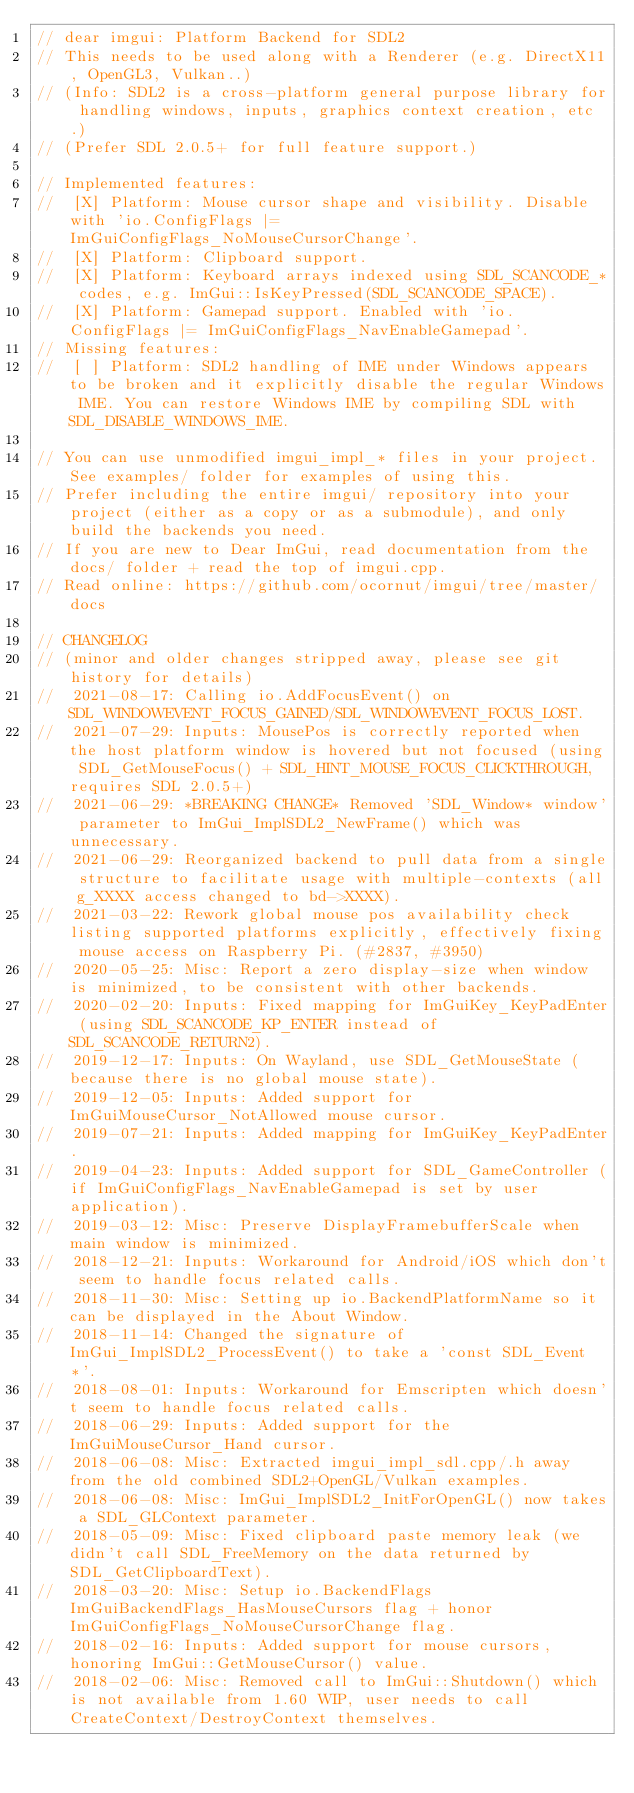Convert code to text. <code><loc_0><loc_0><loc_500><loc_500><_C++_>// dear imgui: Platform Backend for SDL2
// This needs to be used along with a Renderer (e.g. DirectX11, OpenGL3, Vulkan..)
// (Info: SDL2 is a cross-platform general purpose library for handling windows, inputs, graphics context creation, etc.)
// (Prefer SDL 2.0.5+ for full feature support.)

// Implemented features:
//  [X] Platform: Mouse cursor shape and visibility. Disable with 'io.ConfigFlags |= ImGuiConfigFlags_NoMouseCursorChange'.
//  [X] Platform: Clipboard support.
//  [X] Platform: Keyboard arrays indexed using SDL_SCANCODE_* codes, e.g. ImGui::IsKeyPressed(SDL_SCANCODE_SPACE).
//  [X] Platform: Gamepad support. Enabled with 'io.ConfigFlags |= ImGuiConfigFlags_NavEnableGamepad'.
// Missing features:
//  [ ] Platform: SDL2 handling of IME under Windows appears to be broken and it explicitly disable the regular Windows IME. You can restore Windows IME by compiling SDL with SDL_DISABLE_WINDOWS_IME.

// You can use unmodified imgui_impl_* files in your project. See examples/ folder for examples of using this.
// Prefer including the entire imgui/ repository into your project (either as a copy or as a submodule), and only build the backends you need.
// If you are new to Dear ImGui, read documentation from the docs/ folder + read the top of imgui.cpp.
// Read online: https://github.com/ocornut/imgui/tree/master/docs

// CHANGELOG
// (minor and older changes stripped away, please see git history for details)
//  2021-08-17: Calling io.AddFocusEvent() on SDL_WINDOWEVENT_FOCUS_GAINED/SDL_WINDOWEVENT_FOCUS_LOST.
//  2021-07-29: Inputs: MousePos is correctly reported when the host platform window is hovered but not focused (using SDL_GetMouseFocus() + SDL_HINT_MOUSE_FOCUS_CLICKTHROUGH, requires SDL 2.0.5+)
//  2021-06-29: *BREAKING CHANGE* Removed 'SDL_Window* window' parameter to ImGui_ImplSDL2_NewFrame() which was unnecessary.
//  2021-06-29: Reorganized backend to pull data from a single structure to facilitate usage with multiple-contexts (all g_XXXX access changed to bd->XXXX).
//  2021-03-22: Rework global mouse pos availability check listing supported platforms explicitly, effectively fixing mouse access on Raspberry Pi. (#2837, #3950)
//  2020-05-25: Misc: Report a zero display-size when window is minimized, to be consistent with other backends.
//  2020-02-20: Inputs: Fixed mapping for ImGuiKey_KeyPadEnter (using SDL_SCANCODE_KP_ENTER instead of SDL_SCANCODE_RETURN2).
//  2019-12-17: Inputs: On Wayland, use SDL_GetMouseState (because there is no global mouse state).
//  2019-12-05: Inputs: Added support for ImGuiMouseCursor_NotAllowed mouse cursor.
//  2019-07-21: Inputs: Added mapping for ImGuiKey_KeyPadEnter.
//  2019-04-23: Inputs: Added support for SDL_GameController (if ImGuiConfigFlags_NavEnableGamepad is set by user application).
//  2019-03-12: Misc: Preserve DisplayFramebufferScale when main window is minimized.
//  2018-12-21: Inputs: Workaround for Android/iOS which don't seem to handle focus related calls.
//  2018-11-30: Misc: Setting up io.BackendPlatformName so it can be displayed in the About Window.
//  2018-11-14: Changed the signature of ImGui_ImplSDL2_ProcessEvent() to take a 'const SDL_Event*'.
//  2018-08-01: Inputs: Workaround for Emscripten which doesn't seem to handle focus related calls.
//  2018-06-29: Inputs: Added support for the ImGuiMouseCursor_Hand cursor.
//  2018-06-08: Misc: Extracted imgui_impl_sdl.cpp/.h away from the old combined SDL2+OpenGL/Vulkan examples.
//  2018-06-08: Misc: ImGui_ImplSDL2_InitForOpenGL() now takes a SDL_GLContext parameter.
//  2018-05-09: Misc: Fixed clipboard paste memory leak (we didn't call SDL_FreeMemory on the data returned by SDL_GetClipboardText).
//  2018-03-20: Misc: Setup io.BackendFlags ImGuiBackendFlags_HasMouseCursors flag + honor ImGuiConfigFlags_NoMouseCursorChange flag.
//  2018-02-16: Inputs: Added support for mouse cursors, honoring ImGui::GetMouseCursor() value.
//  2018-02-06: Misc: Removed call to ImGui::Shutdown() which is not available from 1.60 WIP, user needs to call CreateContext/DestroyContext themselves.</code> 